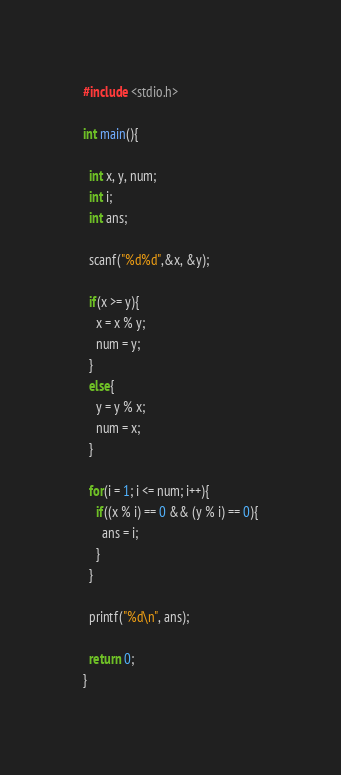Convert code to text. <code><loc_0><loc_0><loc_500><loc_500><_C_>#include <stdio.h>

int main(){

  int x, y, num;
  int i;
  int ans;
  
  scanf("%d%d",&x, &y);
  
  if(x >= y){
    x = x % y;
    num = y;
  }
  else{
    y = y % x;
    num = x;
  }
  
  for(i = 1; i <= num; i++){
    if((x % i) == 0 && (y % i) == 0){
      ans = i;
    }
  }
  
  printf("%d\n", ans);
  
  return 0;
}

</code> 